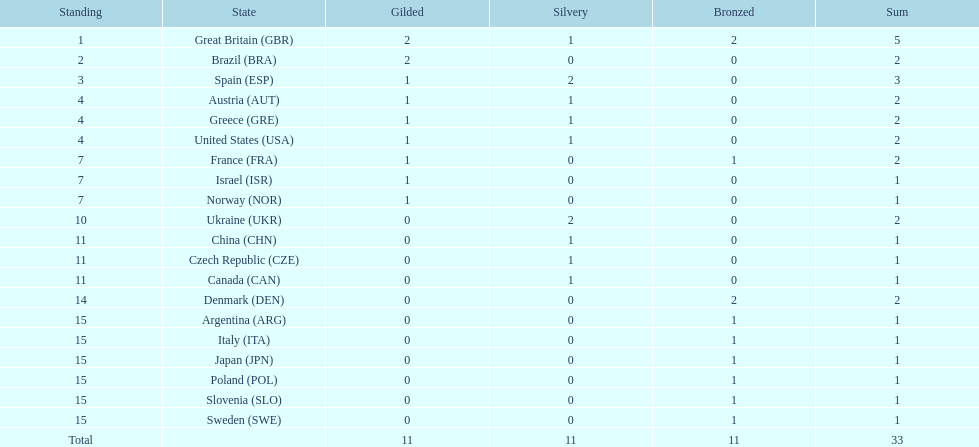Who won more gold medals than spain? Great Britain (GBR), Brazil (BRA). 